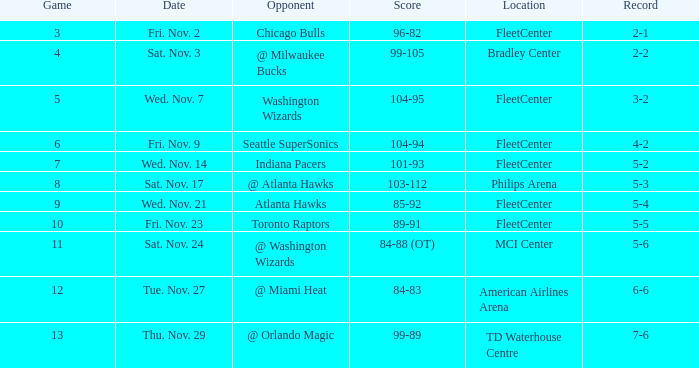What is the number of games with a score range of 85-92? 1.0. 